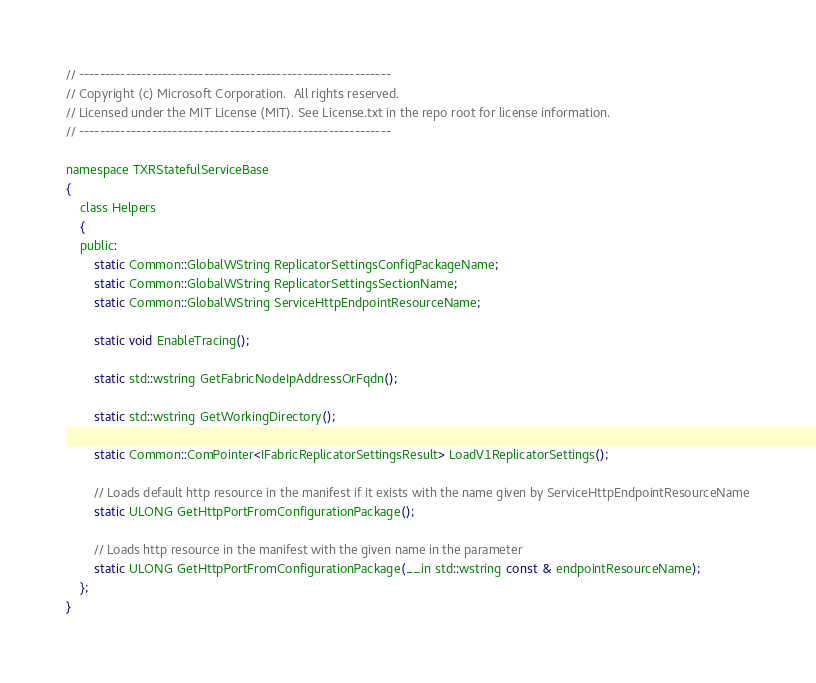<code> <loc_0><loc_0><loc_500><loc_500><_C_>// ------------------------------------------------------------
// Copyright (c) Microsoft Corporation.  All rights reserved.
// Licensed under the MIT License (MIT). See License.txt in the repo root for license information.
// ------------------------------------------------------------

namespace TXRStatefulServiceBase
{
    class Helpers
    {
    public:
        static Common::GlobalWString ReplicatorSettingsConfigPackageName;
        static Common::GlobalWString ReplicatorSettingsSectionName;
        static Common::GlobalWString ServiceHttpEndpointResourceName;

        static void EnableTracing();

        static std::wstring GetFabricNodeIpAddressOrFqdn();

        static std::wstring GetWorkingDirectory();

        static Common::ComPointer<IFabricReplicatorSettingsResult> LoadV1ReplicatorSettings();
        
        // Loads default http resource in the manifest if it exists with the name given by ServiceHttpEndpointResourceName
        static ULONG GetHttpPortFromConfigurationPackage();

        // Loads http resource in the manifest with the given name in the parameter
        static ULONG GetHttpPortFromConfigurationPackage(__in std::wstring const & endpointResourceName);
    };
}
</code> 